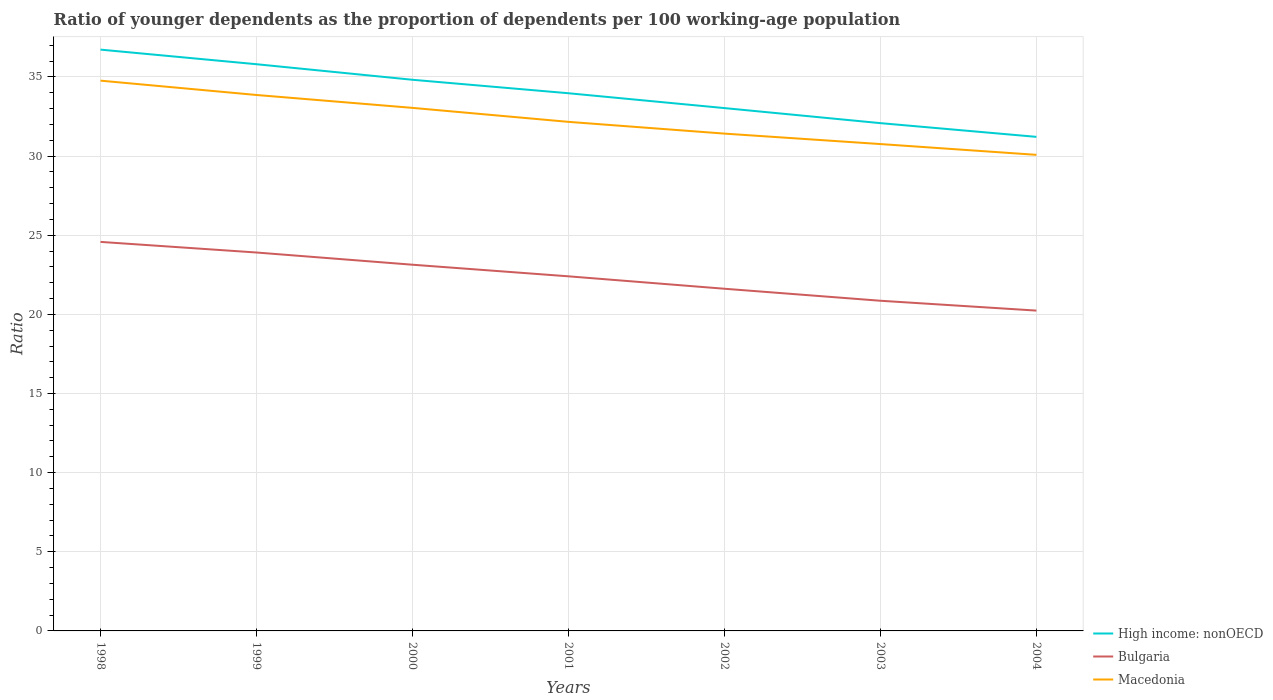How many different coloured lines are there?
Your answer should be compact. 3. Across all years, what is the maximum age dependency ratio(young) in Macedonia?
Your answer should be very brief. 30.08. What is the total age dependency ratio(young) in Bulgaria in the graph?
Ensure brevity in your answer.  2.17. What is the difference between the highest and the second highest age dependency ratio(young) in High income: nonOECD?
Your answer should be compact. 5.51. Does the graph contain any zero values?
Offer a terse response. No. Where does the legend appear in the graph?
Your answer should be compact. Bottom right. What is the title of the graph?
Your answer should be very brief. Ratio of younger dependents as the proportion of dependents per 100 working-age population. Does "Somalia" appear as one of the legend labels in the graph?
Offer a very short reply. No. What is the label or title of the Y-axis?
Provide a succinct answer. Ratio. What is the Ratio of High income: nonOECD in 1998?
Keep it short and to the point. 36.73. What is the Ratio of Bulgaria in 1998?
Your answer should be very brief. 24.58. What is the Ratio in Macedonia in 1998?
Your response must be concise. 34.77. What is the Ratio of High income: nonOECD in 1999?
Make the answer very short. 35.8. What is the Ratio in Bulgaria in 1999?
Give a very brief answer. 23.91. What is the Ratio of Macedonia in 1999?
Provide a short and direct response. 33.86. What is the Ratio of High income: nonOECD in 2000?
Provide a short and direct response. 34.82. What is the Ratio in Bulgaria in 2000?
Your response must be concise. 23.14. What is the Ratio in Macedonia in 2000?
Offer a very short reply. 33.05. What is the Ratio of High income: nonOECD in 2001?
Provide a short and direct response. 33.97. What is the Ratio in Bulgaria in 2001?
Your answer should be compact. 22.4. What is the Ratio of Macedonia in 2001?
Provide a succinct answer. 32.16. What is the Ratio of High income: nonOECD in 2002?
Make the answer very short. 33.03. What is the Ratio of Bulgaria in 2002?
Your response must be concise. 21.62. What is the Ratio of Macedonia in 2002?
Make the answer very short. 31.42. What is the Ratio of High income: nonOECD in 2003?
Your answer should be compact. 32.08. What is the Ratio of Bulgaria in 2003?
Your answer should be very brief. 20.86. What is the Ratio in Macedonia in 2003?
Make the answer very short. 30.76. What is the Ratio in High income: nonOECD in 2004?
Your response must be concise. 31.21. What is the Ratio of Bulgaria in 2004?
Your answer should be compact. 20.24. What is the Ratio of Macedonia in 2004?
Your response must be concise. 30.08. Across all years, what is the maximum Ratio in High income: nonOECD?
Provide a succinct answer. 36.73. Across all years, what is the maximum Ratio in Bulgaria?
Give a very brief answer. 24.58. Across all years, what is the maximum Ratio of Macedonia?
Keep it short and to the point. 34.77. Across all years, what is the minimum Ratio of High income: nonOECD?
Provide a succinct answer. 31.21. Across all years, what is the minimum Ratio of Bulgaria?
Ensure brevity in your answer.  20.24. Across all years, what is the minimum Ratio in Macedonia?
Offer a very short reply. 30.08. What is the total Ratio of High income: nonOECD in the graph?
Keep it short and to the point. 237.65. What is the total Ratio in Bulgaria in the graph?
Your response must be concise. 156.74. What is the total Ratio in Macedonia in the graph?
Offer a terse response. 226.09. What is the difference between the Ratio of High income: nonOECD in 1998 and that in 1999?
Offer a very short reply. 0.92. What is the difference between the Ratio of Bulgaria in 1998 and that in 1999?
Provide a succinct answer. 0.67. What is the difference between the Ratio of Macedonia in 1998 and that in 1999?
Keep it short and to the point. 0.91. What is the difference between the Ratio in High income: nonOECD in 1998 and that in 2000?
Provide a short and direct response. 1.91. What is the difference between the Ratio of Bulgaria in 1998 and that in 2000?
Provide a succinct answer. 1.44. What is the difference between the Ratio of Macedonia in 1998 and that in 2000?
Provide a succinct answer. 1.72. What is the difference between the Ratio in High income: nonOECD in 1998 and that in 2001?
Ensure brevity in your answer.  2.76. What is the difference between the Ratio of Bulgaria in 1998 and that in 2001?
Your answer should be very brief. 2.17. What is the difference between the Ratio of Macedonia in 1998 and that in 2001?
Offer a terse response. 2.6. What is the difference between the Ratio in High income: nonOECD in 1998 and that in 2002?
Keep it short and to the point. 3.69. What is the difference between the Ratio in Bulgaria in 1998 and that in 2002?
Give a very brief answer. 2.96. What is the difference between the Ratio in Macedonia in 1998 and that in 2002?
Keep it short and to the point. 3.35. What is the difference between the Ratio in High income: nonOECD in 1998 and that in 2003?
Provide a succinct answer. 4.64. What is the difference between the Ratio of Bulgaria in 1998 and that in 2003?
Offer a very short reply. 3.72. What is the difference between the Ratio of Macedonia in 1998 and that in 2003?
Make the answer very short. 4.01. What is the difference between the Ratio of High income: nonOECD in 1998 and that in 2004?
Offer a terse response. 5.51. What is the difference between the Ratio of Bulgaria in 1998 and that in 2004?
Ensure brevity in your answer.  4.34. What is the difference between the Ratio in Macedonia in 1998 and that in 2004?
Keep it short and to the point. 4.69. What is the difference between the Ratio of High income: nonOECD in 1999 and that in 2000?
Your answer should be compact. 0.98. What is the difference between the Ratio in Bulgaria in 1999 and that in 2000?
Provide a short and direct response. 0.77. What is the difference between the Ratio of Macedonia in 1999 and that in 2000?
Ensure brevity in your answer.  0.81. What is the difference between the Ratio in High income: nonOECD in 1999 and that in 2001?
Your answer should be very brief. 1.83. What is the difference between the Ratio of Bulgaria in 1999 and that in 2001?
Give a very brief answer. 1.5. What is the difference between the Ratio in Macedonia in 1999 and that in 2001?
Your answer should be very brief. 1.7. What is the difference between the Ratio of High income: nonOECD in 1999 and that in 2002?
Give a very brief answer. 2.77. What is the difference between the Ratio of Bulgaria in 1999 and that in 2002?
Your response must be concise. 2.29. What is the difference between the Ratio of Macedonia in 1999 and that in 2002?
Your answer should be compact. 2.44. What is the difference between the Ratio in High income: nonOECD in 1999 and that in 2003?
Offer a very short reply. 3.72. What is the difference between the Ratio in Bulgaria in 1999 and that in 2003?
Ensure brevity in your answer.  3.05. What is the difference between the Ratio in Macedonia in 1999 and that in 2003?
Provide a short and direct response. 3.1. What is the difference between the Ratio in High income: nonOECD in 1999 and that in 2004?
Your answer should be very brief. 4.59. What is the difference between the Ratio of Bulgaria in 1999 and that in 2004?
Your answer should be very brief. 3.67. What is the difference between the Ratio in Macedonia in 1999 and that in 2004?
Ensure brevity in your answer.  3.78. What is the difference between the Ratio in High income: nonOECD in 2000 and that in 2001?
Provide a succinct answer. 0.85. What is the difference between the Ratio of Bulgaria in 2000 and that in 2001?
Your answer should be very brief. 0.73. What is the difference between the Ratio of Macedonia in 2000 and that in 2001?
Your answer should be compact. 0.88. What is the difference between the Ratio in High income: nonOECD in 2000 and that in 2002?
Offer a terse response. 1.79. What is the difference between the Ratio in Bulgaria in 2000 and that in 2002?
Give a very brief answer. 1.52. What is the difference between the Ratio of Macedonia in 2000 and that in 2002?
Your answer should be very brief. 1.63. What is the difference between the Ratio in High income: nonOECD in 2000 and that in 2003?
Give a very brief answer. 2.74. What is the difference between the Ratio of Bulgaria in 2000 and that in 2003?
Give a very brief answer. 2.28. What is the difference between the Ratio of Macedonia in 2000 and that in 2003?
Give a very brief answer. 2.29. What is the difference between the Ratio of High income: nonOECD in 2000 and that in 2004?
Offer a very short reply. 3.61. What is the difference between the Ratio of Bulgaria in 2000 and that in 2004?
Provide a short and direct response. 2.9. What is the difference between the Ratio of Macedonia in 2000 and that in 2004?
Keep it short and to the point. 2.97. What is the difference between the Ratio in High income: nonOECD in 2001 and that in 2002?
Your answer should be very brief. 0.94. What is the difference between the Ratio of Bulgaria in 2001 and that in 2002?
Keep it short and to the point. 0.78. What is the difference between the Ratio in Macedonia in 2001 and that in 2002?
Keep it short and to the point. 0.74. What is the difference between the Ratio in High income: nonOECD in 2001 and that in 2003?
Provide a succinct answer. 1.89. What is the difference between the Ratio of Bulgaria in 2001 and that in 2003?
Your answer should be very brief. 1.54. What is the difference between the Ratio of Macedonia in 2001 and that in 2003?
Your answer should be compact. 1.4. What is the difference between the Ratio of High income: nonOECD in 2001 and that in 2004?
Offer a very short reply. 2.76. What is the difference between the Ratio in Bulgaria in 2001 and that in 2004?
Ensure brevity in your answer.  2.17. What is the difference between the Ratio in Macedonia in 2001 and that in 2004?
Give a very brief answer. 2.08. What is the difference between the Ratio of High income: nonOECD in 2002 and that in 2003?
Provide a succinct answer. 0.95. What is the difference between the Ratio in Bulgaria in 2002 and that in 2003?
Give a very brief answer. 0.76. What is the difference between the Ratio of Macedonia in 2002 and that in 2003?
Ensure brevity in your answer.  0.66. What is the difference between the Ratio in High income: nonOECD in 2002 and that in 2004?
Provide a succinct answer. 1.82. What is the difference between the Ratio in Bulgaria in 2002 and that in 2004?
Give a very brief answer. 1.38. What is the difference between the Ratio in Macedonia in 2002 and that in 2004?
Give a very brief answer. 1.34. What is the difference between the Ratio of High income: nonOECD in 2003 and that in 2004?
Your response must be concise. 0.87. What is the difference between the Ratio in Bulgaria in 2003 and that in 2004?
Offer a terse response. 0.62. What is the difference between the Ratio in Macedonia in 2003 and that in 2004?
Keep it short and to the point. 0.68. What is the difference between the Ratio in High income: nonOECD in 1998 and the Ratio in Bulgaria in 1999?
Your answer should be very brief. 12.82. What is the difference between the Ratio of High income: nonOECD in 1998 and the Ratio of Macedonia in 1999?
Offer a terse response. 2.87. What is the difference between the Ratio in Bulgaria in 1998 and the Ratio in Macedonia in 1999?
Provide a short and direct response. -9.28. What is the difference between the Ratio of High income: nonOECD in 1998 and the Ratio of Bulgaria in 2000?
Provide a short and direct response. 13.59. What is the difference between the Ratio in High income: nonOECD in 1998 and the Ratio in Macedonia in 2000?
Your answer should be very brief. 3.68. What is the difference between the Ratio of Bulgaria in 1998 and the Ratio of Macedonia in 2000?
Provide a short and direct response. -8.47. What is the difference between the Ratio in High income: nonOECD in 1998 and the Ratio in Bulgaria in 2001?
Your answer should be compact. 14.32. What is the difference between the Ratio of High income: nonOECD in 1998 and the Ratio of Macedonia in 2001?
Offer a terse response. 4.56. What is the difference between the Ratio of Bulgaria in 1998 and the Ratio of Macedonia in 2001?
Give a very brief answer. -7.58. What is the difference between the Ratio in High income: nonOECD in 1998 and the Ratio in Bulgaria in 2002?
Provide a short and direct response. 15.11. What is the difference between the Ratio of High income: nonOECD in 1998 and the Ratio of Macedonia in 2002?
Make the answer very short. 5.31. What is the difference between the Ratio of Bulgaria in 1998 and the Ratio of Macedonia in 2002?
Give a very brief answer. -6.84. What is the difference between the Ratio in High income: nonOECD in 1998 and the Ratio in Bulgaria in 2003?
Your answer should be compact. 15.87. What is the difference between the Ratio of High income: nonOECD in 1998 and the Ratio of Macedonia in 2003?
Your response must be concise. 5.97. What is the difference between the Ratio in Bulgaria in 1998 and the Ratio in Macedonia in 2003?
Offer a very short reply. -6.18. What is the difference between the Ratio in High income: nonOECD in 1998 and the Ratio in Bulgaria in 2004?
Offer a terse response. 16.49. What is the difference between the Ratio in High income: nonOECD in 1998 and the Ratio in Macedonia in 2004?
Ensure brevity in your answer.  6.65. What is the difference between the Ratio of Bulgaria in 1998 and the Ratio of Macedonia in 2004?
Offer a terse response. -5.5. What is the difference between the Ratio in High income: nonOECD in 1999 and the Ratio in Bulgaria in 2000?
Ensure brevity in your answer.  12.67. What is the difference between the Ratio in High income: nonOECD in 1999 and the Ratio in Macedonia in 2000?
Offer a terse response. 2.76. What is the difference between the Ratio of Bulgaria in 1999 and the Ratio of Macedonia in 2000?
Give a very brief answer. -9.14. What is the difference between the Ratio of High income: nonOECD in 1999 and the Ratio of Bulgaria in 2001?
Offer a terse response. 13.4. What is the difference between the Ratio in High income: nonOECD in 1999 and the Ratio in Macedonia in 2001?
Make the answer very short. 3.64. What is the difference between the Ratio of Bulgaria in 1999 and the Ratio of Macedonia in 2001?
Your response must be concise. -8.25. What is the difference between the Ratio of High income: nonOECD in 1999 and the Ratio of Bulgaria in 2002?
Give a very brief answer. 14.19. What is the difference between the Ratio of High income: nonOECD in 1999 and the Ratio of Macedonia in 2002?
Provide a short and direct response. 4.38. What is the difference between the Ratio in Bulgaria in 1999 and the Ratio in Macedonia in 2002?
Ensure brevity in your answer.  -7.51. What is the difference between the Ratio of High income: nonOECD in 1999 and the Ratio of Bulgaria in 2003?
Make the answer very short. 14.94. What is the difference between the Ratio in High income: nonOECD in 1999 and the Ratio in Macedonia in 2003?
Keep it short and to the point. 5.04. What is the difference between the Ratio in Bulgaria in 1999 and the Ratio in Macedonia in 2003?
Keep it short and to the point. -6.85. What is the difference between the Ratio of High income: nonOECD in 1999 and the Ratio of Bulgaria in 2004?
Make the answer very short. 15.57. What is the difference between the Ratio of High income: nonOECD in 1999 and the Ratio of Macedonia in 2004?
Your answer should be very brief. 5.73. What is the difference between the Ratio in Bulgaria in 1999 and the Ratio in Macedonia in 2004?
Your answer should be very brief. -6.17. What is the difference between the Ratio of High income: nonOECD in 2000 and the Ratio of Bulgaria in 2001?
Keep it short and to the point. 12.42. What is the difference between the Ratio of High income: nonOECD in 2000 and the Ratio of Macedonia in 2001?
Keep it short and to the point. 2.66. What is the difference between the Ratio in Bulgaria in 2000 and the Ratio in Macedonia in 2001?
Offer a very short reply. -9.03. What is the difference between the Ratio in High income: nonOECD in 2000 and the Ratio in Bulgaria in 2002?
Offer a very short reply. 13.2. What is the difference between the Ratio in High income: nonOECD in 2000 and the Ratio in Macedonia in 2002?
Your answer should be compact. 3.4. What is the difference between the Ratio in Bulgaria in 2000 and the Ratio in Macedonia in 2002?
Provide a succinct answer. -8.28. What is the difference between the Ratio in High income: nonOECD in 2000 and the Ratio in Bulgaria in 2003?
Your answer should be very brief. 13.96. What is the difference between the Ratio of High income: nonOECD in 2000 and the Ratio of Macedonia in 2003?
Keep it short and to the point. 4.06. What is the difference between the Ratio of Bulgaria in 2000 and the Ratio of Macedonia in 2003?
Make the answer very short. -7.62. What is the difference between the Ratio in High income: nonOECD in 2000 and the Ratio in Bulgaria in 2004?
Provide a short and direct response. 14.58. What is the difference between the Ratio in High income: nonOECD in 2000 and the Ratio in Macedonia in 2004?
Offer a terse response. 4.74. What is the difference between the Ratio in Bulgaria in 2000 and the Ratio in Macedonia in 2004?
Give a very brief answer. -6.94. What is the difference between the Ratio in High income: nonOECD in 2001 and the Ratio in Bulgaria in 2002?
Give a very brief answer. 12.35. What is the difference between the Ratio of High income: nonOECD in 2001 and the Ratio of Macedonia in 2002?
Offer a terse response. 2.55. What is the difference between the Ratio of Bulgaria in 2001 and the Ratio of Macedonia in 2002?
Provide a short and direct response. -9.02. What is the difference between the Ratio of High income: nonOECD in 2001 and the Ratio of Bulgaria in 2003?
Your response must be concise. 13.11. What is the difference between the Ratio of High income: nonOECD in 2001 and the Ratio of Macedonia in 2003?
Ensure brevity in your answer.  3.21. What is the difference between the Ratio in Bulgaria in 2001 and the Ratio in Macedonia in 2003?
Make the answer very short. -8.36. What is the difference between the Ratio in High income: nonOECD in 2001 and the Ratio in Bulgaria in 2004?
Your response must be concise. 13.73. What is the difference between the Ratio in High income: nonOECD in 2001 and the Ratio in Macedonia in 2004?
Offer a very short reply. 3.89. What is the difference between the Ratio in Bulgaria in 2001 and the Ratio in Macedonia in 2004?
Offer a terse response. -7.67. What is the difference between the Ratio of High income: nonOECD in 2002 and the Ratio of Bulgaria in 2003?
Your response must be concise. 12.17. What is the difference between the Ratio in High income: nonOECD in 2002 and the Ratio in Macedonia in 2003?
Give a very brief answer. 2.27. What is the difference between the Ratio in Bulgaria in 2002 and the Ratio in Macedonia in 2003?
Offer a very short reply. -9.14. What is the difference between the Ratio of High income: nonOECD in 2002 and the Ratio of Bulgaria in 2004?
Your answer should be very brief. 12.79. What is the difference between the Ratio of High income: nonOECD in 2002 and the Ratio of Macedonia in 2004?
Provide a succinct answer. 2.95. What is the difference between the Ratio in Bulgaria in 2002 and the Ratio in Macedonia in 2004?
Provide a short and direct response. -8.46. What is the difference between the Ratio of High income: nonOECD in 2003 and the Ratio of Bulgaria in 2004?
Make the answer very short. 11.84. What is the difference between the Ratio in High income: nonOECD in 2003 and the Ratio in Macedonia in 2004?
Provide a short and direct response. 2. What is the difference between the Ratio of Bulgaria in 2003 and the Ratio of Macedonia in 2004?
Offer a terse response. -9.22. What is the average Ratio in High income: nonOECD per year?
Ensure brevity in your answer.  33.95. What is the average Ratio of Bulgaria per year?
Keep it short and to the point. 22.39. What is the average Ratio in Macedonia per year?
Your answer should be very brief. 32.3. In the year 1998, what is the difference between the Ratio of High income: nonOECD and Ratio of Bulgaria?
Provide a short and direct response. 12.15. In the year 1998, what is the difference between the Ratio in High income: nonOECD and Ratio in Macedonia?
Give a very brief answer. 1.96. In the year 1998, what is the difference between the Ratio in Bulgaria and Ratio in Macedonia?
Ensure brevity in your answer.  -10.19. In the year 1999, what is the difference between the Ratio of High income: nonOECD and Ratio of Bulgaria?
Provide a succinct answer. 11.9. In the year 1999, what is the difference between the Ratio of High income: nonOECD and Ratio of Macedonia?
Ensure brevity in your answer.  1.94. In the year 1999, what is the difference between the Ratio in Bulgaria and Ratio in Macedonia?
Your answer should be compact. -9.95. In the year 2000, what is the difference between the Ratio of High income: nonOECD and Ratio of Bulgaria?
Keep it short and to the point. 11.68. In the year 2000, what is the difference between the Ratio of High income: nonOECD and Ratio of Macedonia?
Give a very brief answer. 1.78. In the year 2000, what is the difference between the Ratio in Bulgaria and Ratio in Macedonia?
Offer a very short reply. -9.91. In the year 2001, what is the difference between the Ratio in High income: nonOECD and Ratio in Bulgaria?
Provide a succinct answer. 11.57. In the year 2001, what is the difference between the Ratio of High income: nonOECD and Ratio of Macedonia?
Keep it short and to the point. 1.81. In the year 2001, what is the difference between the Ratio of Bulgaria and Ratio of Macedonia?
Keep it short and to the point. -9.76. In the year 2002, what is the difference between the Ratio in High income: nonOECD and Ratio in Bulgaria?
Your answer should be very brief. 11.41. In the year 2002, what is the difference between the Ratio of High income: nonOECD and Ratio of Macedonia?
Offer a terse response. 1.61. In the year 2002, what is the difference between the Ratio in Bulgaria and Ratio in Macedonia?
Your response must be concise. -9.8. In the year 2003, what is the difference between the Ratio in High income: nonOECD and Ratio in Bulgaria?
Make the answer very short. 11.22. In the year 2003, what is the difference between the Ratio in High income: nonOECD and Ratio in Macedonia?
Give a very brief answer. 1.32. In the year 2003, what is the difference between the Ratio in Bulgaria and Ratio in Macedonia?
Offer a terse response. -9.9. In the year 2004, what is the difference between the Ratio in High income: nonOECD and Ratio in Bulgaria?
Your response must be concise. 10.98. In the year 2004, what is the difference between the Ratio in High income: nonOECD and Ratio in Macedonia?
Ensure brevity in your answer.  1.14. In the year 2004, what is the difference between the Ratio of Bulgaria and Ratio of Macedonia?
Your response must be concise. -9.84. What is the ratio of the Ratio in High income: nonOECD in 1998 to that in 1999?
Offer a terse response. 1.03. What is the ratio of the Ratio of Bulgaria in 1998 to that in 1999?
Your answer should be very brief. 1.03. What is the ratio of the Ratio of Macedonia in 1998 to that in 1999?
Keep it short and to the point. 1.03. What is the ratio of the Ratio in High income: nonOECD in 1998 to that in 2000?
Offer a very short reply. 1.05. What is the ratio of the Ratio of Bulgaria in 1998 to that in 2000?
Provide a succinct answer. 1.06. What is the ratio of the Ratio of Macedonia in 1998 to that in 2000?
Provide a short and direct response. 1.05. What is the ratio of the Ratio in High income: nonOECD in 1998 to that in 2001?
Your answer should be very brief. 1.08. What is the ratio of the Ratio in Bulgaria in 1998 to that in 2001?
Your answer should be very brief. 1.1. What is the ratio of the Ratio in Macedonia in 1998 to that in 2001?
Give a very brief answer. 1.08. What is the ratio of the Ratio in High income: nonOECD in 1998 to that in 2002?
Your answer should be compact. 1.11. What is the ratio of the Ratio of Bulgaria in 1998 to that in 2002?
Offer a terse response. 1.14. What is the ratio of the Ratio in Macedonia in 1998 to that in 2002?
Make the answer very short. 1.11. What is the ratio of the Ratio in High income: nonOECD in 1998 to that in 2003?
Keep it short and to the point. 1.14. What is the ratio of the Ratio of Bulgaria in 1998 to that in 2003?
Keep it short and to the point. 1.18. What is the ratio of the Ratio in Macedonia in 1998 to that in 2003?
Give a very brief answer. 1.13. What is the ratio of the Ratio in High income: nonOECD in 1998 to that in 2004?
Keep it short and to the point. 1.18. What is the ratio of the Ratio of Bulgaria in 1998 to that in 2004?
Your response must be concise. 1.21. What is the ratio of the Ratio in Macedonia in 1998 to that in 2004?
Give a very brief answer. 1.16. What is the ratio of the Ratio in High income: nonOECD in 1999 to that in 2000?
Ensure brevity in your answer.  1.03. What is the ratio of the Ratio in Bulgaria in 1999 to that in 2000?
Give a very brief answer. 1.03. What is the ratio of the Ratio in Macedonia in 1999 to that in 2000?
Offer a very short reply. 1.02. What is the ratio of the Ratio in High income: nonOECD in 1999 to that in 2001?
Offer a very short reply. 1.05. What is the ratio of the Ratio of Bulgaria in 1999 to that in 2001?
Ensure brevity in your answer.  1.07. What is the ratio of the Ratio in Macedonia in 1999 to that in 2001?
Make the answer very short. 1.05. What is the ratio of the Ratio of High income: nonOECD in 1999 to that in 2002?
Ensure brevity in your answer.  1.08. What is the ratio of the Ratio in Bulgaria in 1999 to that in 2002?
Give a very brief answer. 1.11. What is the ratio of the Ratio of Macedonia in 1999 to that in 2002?
Provide a succinct answer. 1.08. What is the ratio of the Ratio in High income: nonOECD in 1999 to that in 2003?
Give a very brief answer. 1.12. What is the ratio of the Ratio of Bulgaria in 1999 to that in 2003?
Give a very brief answer. 1.15. What is the ratio of the Ratio in Macedonia in 1999 to that in 2003?
Keep it short and to the point. 1.1. What is the ratio of the Ratio in High income: nonOECD in 1999 to that in 2004?
Provide a short and direct response. 1.15. What is the ratio of the Ratio of Bulgaria in 1999 to that in 2004?
Offer a terse response. 1.18. What is the ratio of the Ratio in Macedonia in 1999 to that in 2004?
Keep it short and to the point. 1.13. What is the ratio of the Ratio in Bulgaria in 2000 to that in 2001?
Your answer should be compact. 1.03. What is the ratio of the Ratio in Macedonia in 2000 to that in 2001?
Provide a short and direct response. 1.03. What is the ratio of the Ratio in High income: nonOECD in 2000 to that in 2002?
Your answer should be compact. 1.05. What is the ratio of the Ratio of Bulgaria in 2000 to that in 2002?
Provide a short and direct response. 1.07. What is the ratio of the Ratio of Macedonia in 2000 to that in 2002?
Your response must be concise. 1.05. What is the ratio of the Ratio in High income: nonOECD in 2000 to that in 2003?
Keep it short and to the point. 1.09. What is the ratio of the Ratio in Bulgaria in 2000 to that in 2003?
Provide a succinct answer. 1.11. What is the ratio of the Ratio in Macedonia in 2000 to that in 2003?
Your response must be concise. 1.07. What is the ratio of the Ratio in High income: nonOECD in 2000 to that in 2004?
Make the answer very short. 1.12. What is the ratio of the Ratio in Bulgaria in 2000 to that in 2004?
Keep it short and to the point. 1.14. What is the ratio of the Ratio in Macedonia in 2000 to that in 2004?
Provide a short and direct response. 1.1. What is the ratio of the Ratio of High income: nonOECD in 2001 to that in 2002?
Your answer should be compact. 1.03. What is the ratio of the Ratio in Bulgaria in 2001 to that in 2002?
Your answer should be compact. 1.04. What is the ratio of the Ratio in Macedonia in 2001 to that in 2002?
Make the answer very short. 1.02. What is the ratio of the Ratio in High income: nonOECD in 2001 to that in 2003?
Offer a very short reply. 1.06. What is the ratio of the Ratio of Bulgaria in 2001 to that in 2003?
Ensure brevity in your answer.  1.07. What is the ratio of the Ratio in Macedonia in 2001 to that in 2003?
Give a very brief answer. 1.05. What is the ratio of the Ratio of High income: nonOECD in 2001 to that in 2004?
Give a very brief answer. 1.09. What is the ratio of the Ratio in Bulgaria in 2001 to that in 2004?
Give a very brief answer. 1.11. What is the ratio of the Ratio in Macedonia in 2001 to that in 2004?
Keep it short and to the point. 1.07. What is the ratio of the Ratio of High income: nonOECD in 2002 to that in 2003?
Offer a very short reply. 1.03. What is the ratio of the Ratio in Bulgaria in 2002 to that in 2003?
Your answer should be compact. 1.04. What is the ratio of the Ratio in Macedonia in 2002 to that in 2003?
Give a very brief answer. 1.02. What is the ratio of the Ratio of High income: nonOECD in 2002 to that in 2004?
Your response must be concise. 1.06. What is the ratio of the Ratio of Bulgaria in 2002 to that in 2004?
Provide a succinct answer. 1.07. What is the ratio of the Ratio of Macedonia in 2002 to that in 2004?
Provide a short and direct response. 1.04. What is the ratio of the Ratio of High income: nonOECD in 2003 to that in 2004?
Your answer should be compact. 1.03. What is the ratio of the Ratio in Bulgaria in 2003 to that in 2004?
Provide a short and direct response. 1.03. What is the ratio of the Ratio of Macedonia in 2003 to that in 2004?
Offer a terse response. 1.02. What is the difference between the highest and the second highest Ratio of High income: nonOECD?
Offer a terse response. 0.92. What is the difference between the highest and the second highest Ratio of Bulgaria?
Offer a terse response. 0.67. What is the difference between the highest and the second highest Ratio of Macedonia?
Your answer should be compact. 0.91. What is the difference between the highest and the lowest Ratio of High income: nonOECD?
Your response must be concise. 5.51. What is the difference between the highest and the lowest Ratio of Bulgaria?
Your answer should be compact. 4.34. What is the difference between the highest and the lowest Ratio in Macedonia?
Offer a very short reply. 4.69. 